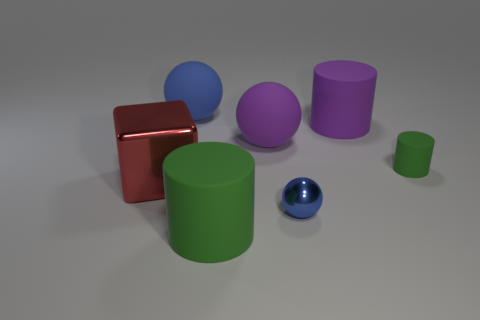What number of other things are there of the same color as the small rubber object?
Give a very brief answer. 1. The big blue rubber object is what shape?
Your answer should be very brief. Sphere. The ball that is both on the right side of the large green thing and behind the tiny blue object is what color?
Give a very brief answer. Purple. There is a red metallic object that is the same size as the purple cylinder; what is its shape?
Provide a succinct answer. Cube. Is there a small blue rubber thing that has the same shape as the large shiny object?
Offer a very short reply. No. Are the big green cylinder and the cube that is left of the tiny metal object made of the same material?
Your response must be concise. No. The rubber object that is to the right of the large thing on the right side of the blue ball right of the large blue thing is what color?
Offer a terse response. Green. There is a purple cylinder that is the same size as the red metal block; what is it made of?
Your answer should be very brief. Rubber. What number of large balls have the same material as the large green object?
Offer a very short reply. 2. There is a blue sphere that is behind the small metal ball; is it the same size as the matte sphere right of the large blue ball?
Your response must be concise. Yes. 